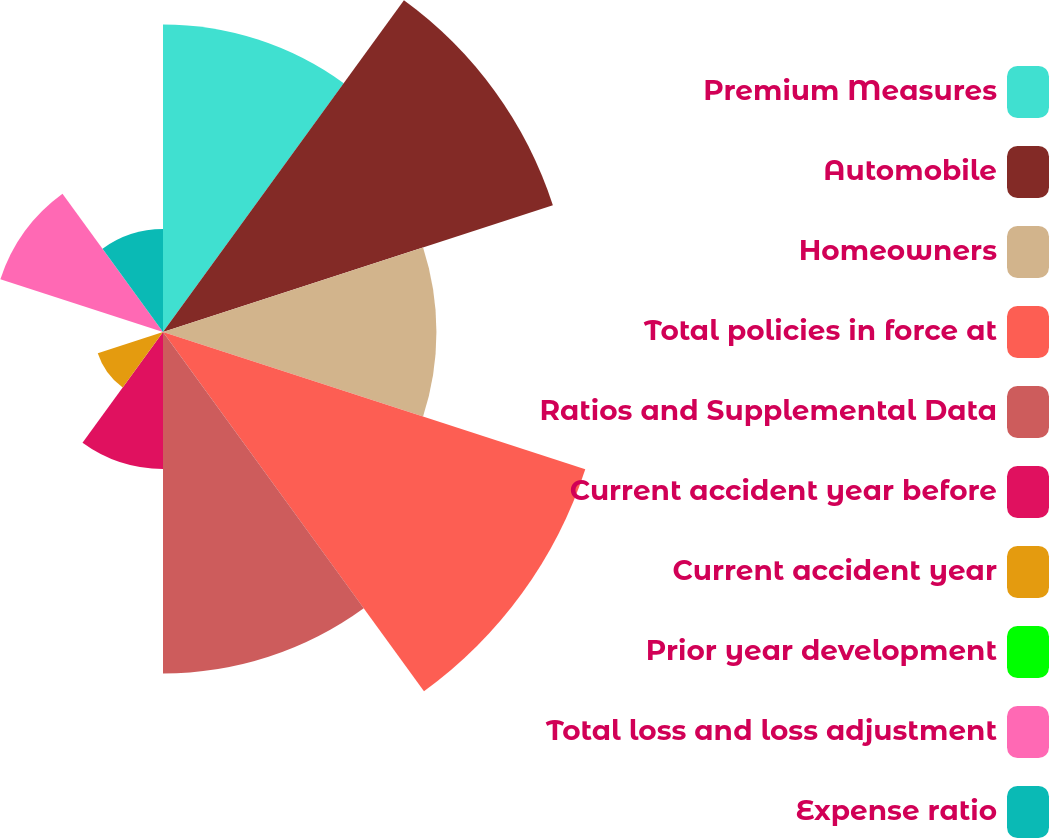Convert chart to OTSL. <chart><loc_0><loc_0><loc_500><loc_500><pie_chart><fcel>Premium Measures<fcel>Automobile<fcel>Homeowners<fcel>Total policies in force at<fcel>Ratios and Supplemental Data<fcel>Current accident year before<fcel>Current accident year<fcel>Prior year development<fcel>Total loss and loss adjustment<fcel>Expense ratio<nl><fcel>13.63%<fcel>18.17%<fcel>12.12%<fcel>19.68%<fcel>15.14%<fcel>6.07%<fcel>3.04%<fcel>0.02%<fcel>7.58%<fcel>4.56%<nl></chart> 